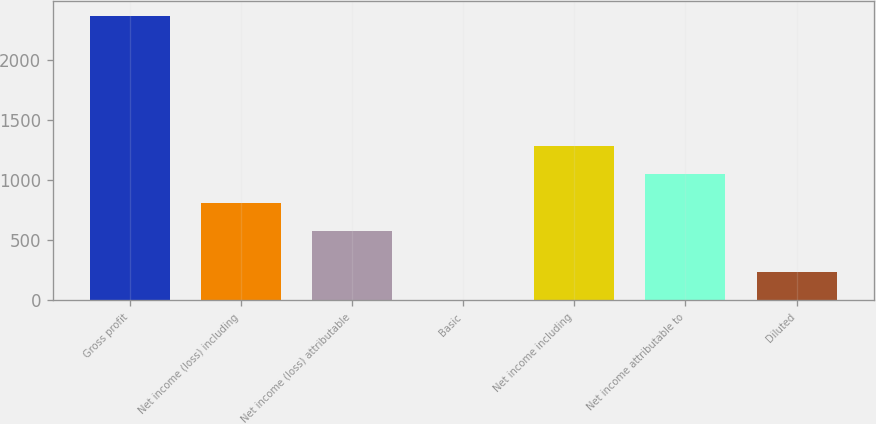Convert chart to OTSL. <chart><loc_0><loc_0><loc_500><loc_500><bar_chart><fcel>Gross profit<fcel>Net income (loss) including<fcel>Net income (loss) attributable<fcel>Basic<fcel>Net income including<fcel>Net income attributable to<fcel>Diluted<nl><fcel>2367<fcel>810.64<fcel>574<fcel>0.63<fcel>1283.92<fcel>1047.28<fcel>237.27<nl></chart> 